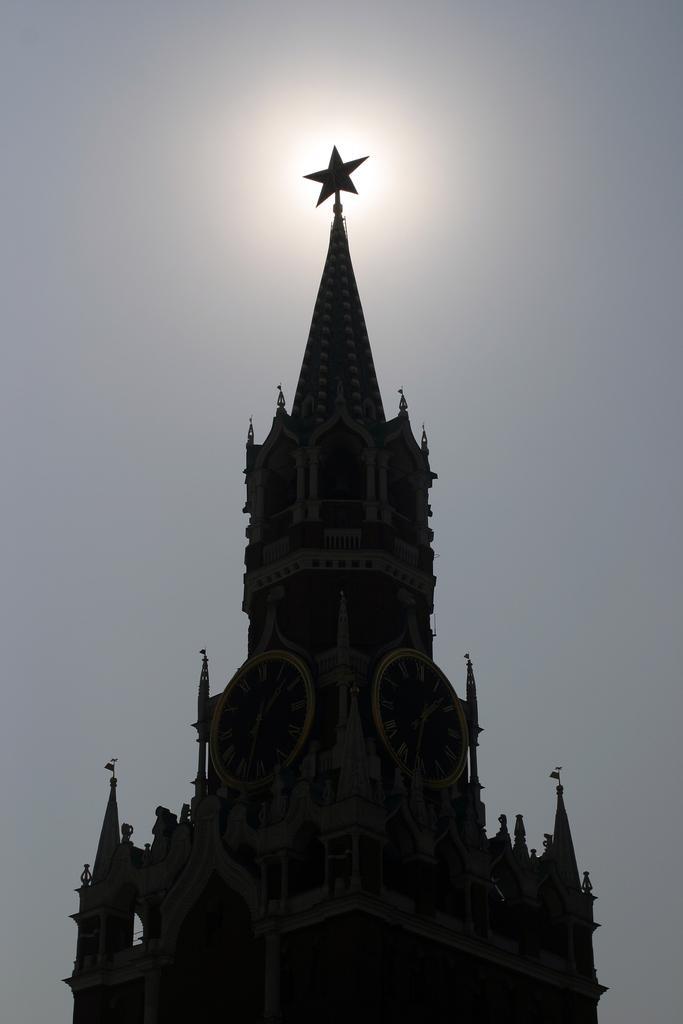In one or two sentences, can you explain what this image depicts? In this image, we can see a building, there are some clocks on the building, at the top there is a sky. 